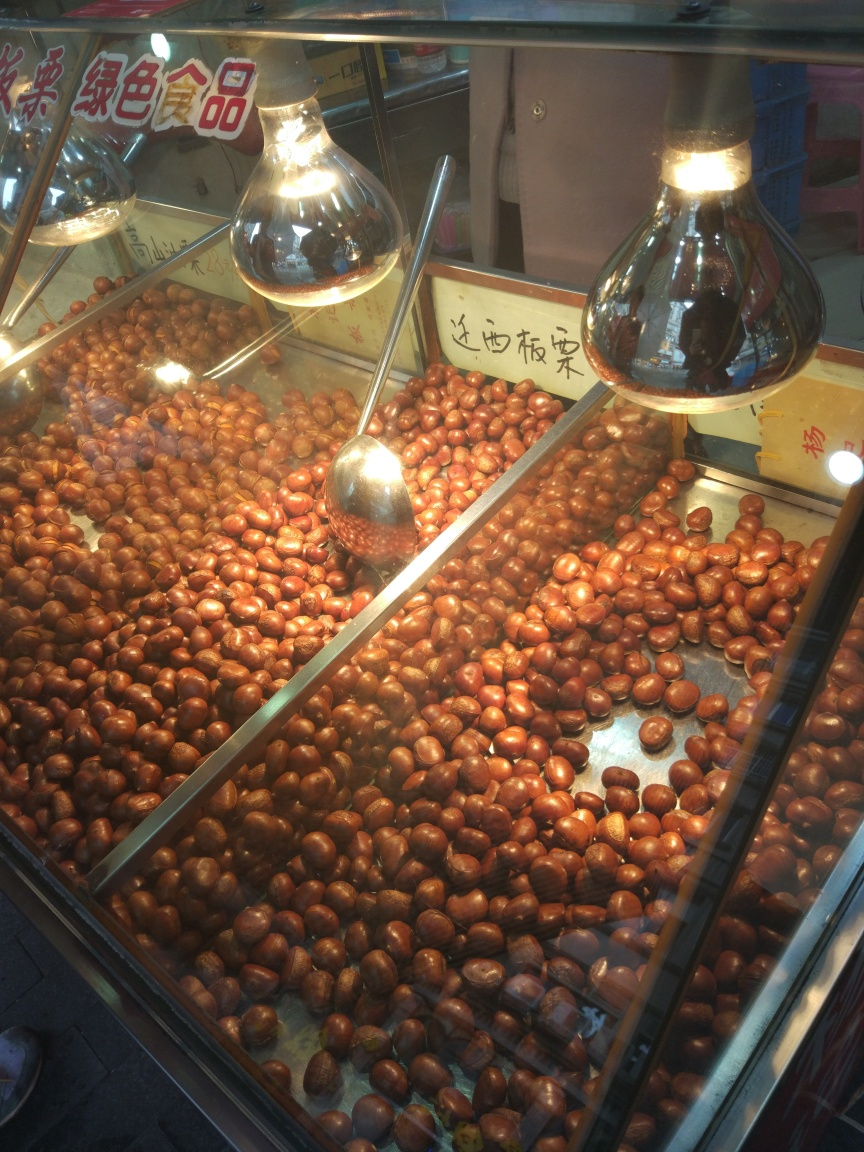What are these items in the display? These are chestnuts, commonly sold as a snack, especially in East Asian markets. They are displayed here under bright lights to accentuate their polished and appetizing appearance. How are they typically prepared or eaten? Chestnuts are versatile and can be eaten raw, roasted, boiled, or incorporated into various dishes. Roasting is a popular street food method, which brings out their sweet, nutty flavor and makes them easier to peel. 